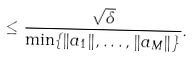<formula> <loc_0><loc_0><loc_500><loc_500>\leq \frac { \sqrt { \delta } } { \min \{ \| a _ { 1 } \| , \dots , \| a _ { M } \| \} } .</formula> 